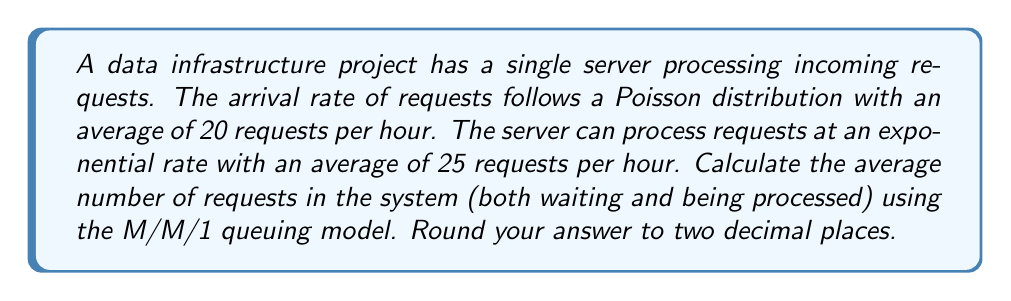Can you answer this question? To solve this problem, we'll use the M/M/1 queuing model, which is appropriate for a single-server system with Poisson arrivals and exponential service times. Let's follow these steps:

1. Identify the given parameters:
   - Arrival rate (λ) = 20 requests/hour
   - Service rate (μ) = 25 requests/hour

2. Calculate the utilization factor (ρ):
   $$\rho = \frac{\lambda}{\mu} = \frac{20}{25} = 0.8$$

3. Use the formula for the average number of requests in the system (L):
   $$L = \frac{\rho}{1 - \rho}$$

4. Substitute the calculated ρ value:
   $$L = \frac{0.8}{1 - 0.8} = \frac{0.8}{0.2} = 4$$

5. Round the result to two decimal places:
   L ≈ 4.00

This result indicates that, on average, there are 4 requests in the system, either being processed or waiting in the queue.
Answer: 4.00 